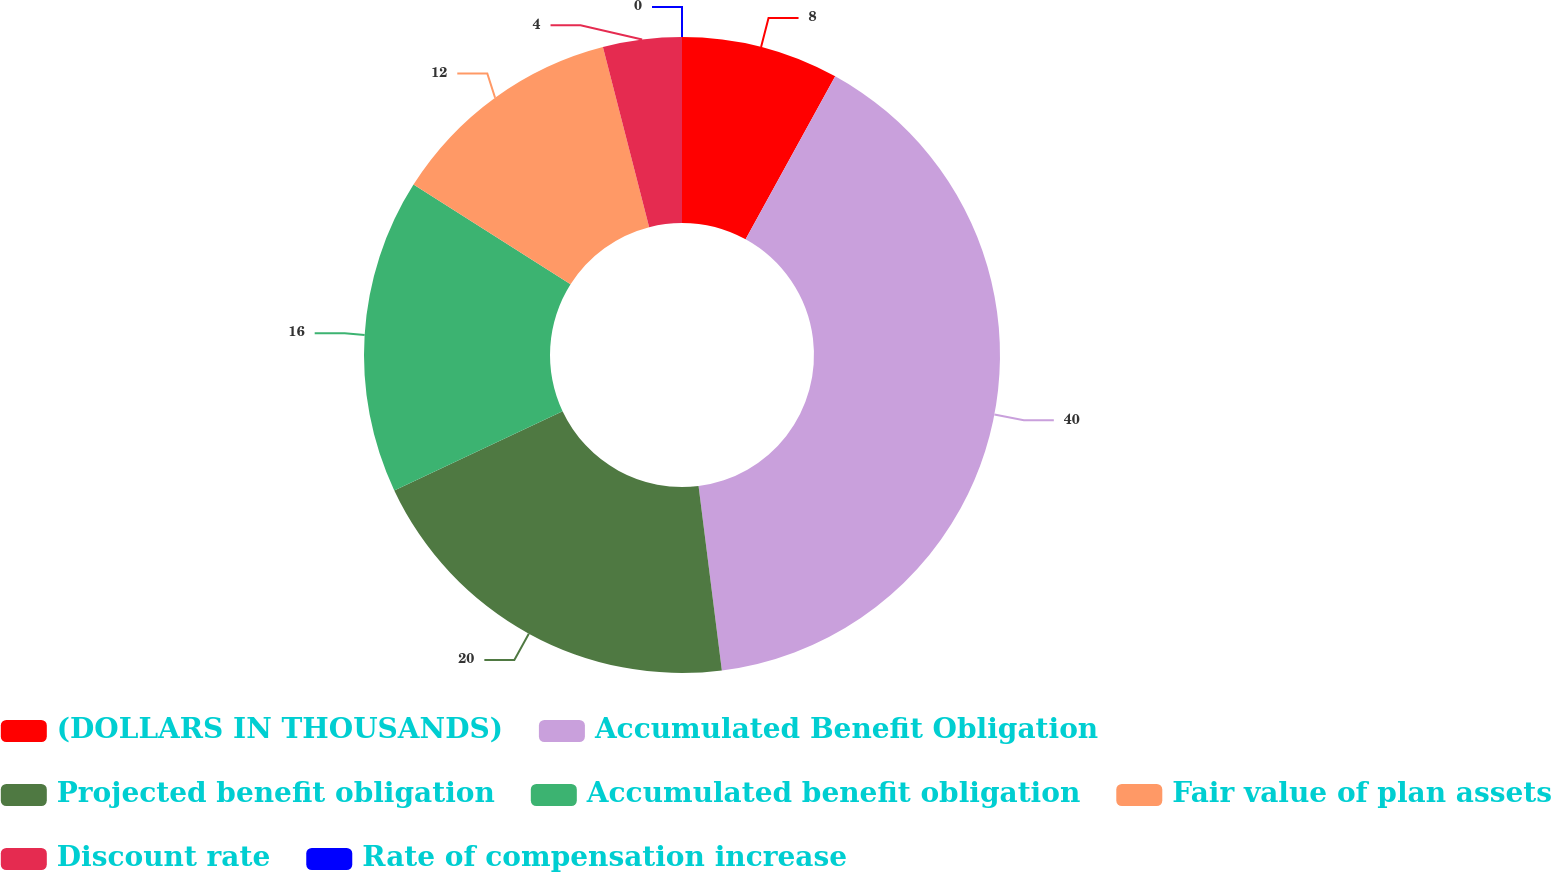Convert chart. <chart><loc_0><loc_0><loc_500><loc_500><pie_chart><fcel>(DOLLARS IN THOUSANDS)<fcel>Accumulated Benefit Obligation<fcel>Projected benefit obligation<fcel>Accumulated benefit obligation<fcel>Fair value of plan assets<fcel>Discount rate<fcel>Rate of compensation increase<nl><fcel>8.0%<fcel>40.0%<fcel>20.0%<fcel>16.0%<fcel>12.0%<fcel>4.0%<fcel>0.0%<nl></chart> 